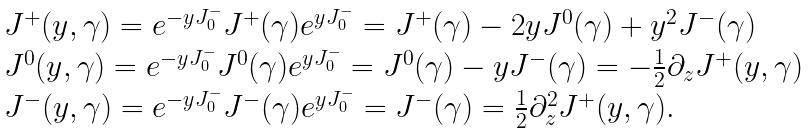Convert formula to latex. <formula><loc_0><loc_0><loc_500><loc_500>\begin{array} { l c r } { { J ^ { + } ( y , \gamma ) = e ^ { - y J _ { 0 } ^ { - } } J ^ { + } ( \gamma ) e ^ { y J _ { 0 } ^ { - } } = J ^ { + } ( \gamma ) - 2 y J ^ { 0 } ( \gamma ) + y ^ { 2 } J ^ { - } ( \gamma ) } } \\ { { J ^ { 0 } ( y , \gamma ) = e ^ { - y J _ { 0 } ^ { - } } J ^ { 0 } ( \gamma ) e ^ { y J _ { 0 } ^ { - } } = J ^ { 0 } ( \gamma ) - y J ^ { - } ( \gamma ) = { - { \frac { 1 } { 2 } } } { \partial _ { z } } J ^ { + } ( y , \gamma ) } } \\ { { J ^ { - } ( y , \gamma ) = e ^ { - y J _ { 0 } ^ { - } } J ^ { - } ( \gamma ) e ^ { y J _ { 0 } ^ { - } } = J ^ { - } ( \gamma ) = { \frac { 1 } { 2 } } { { \partial } _ { z } ^ { 2 } } J ^ { + } ( y , \gamma ) . } } \end{array}</formula> 